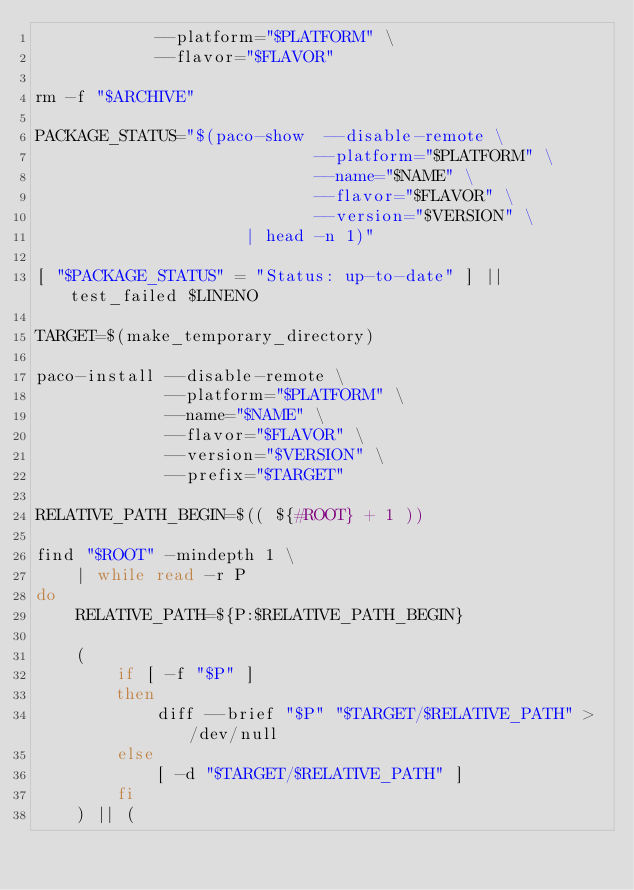<code> <loc_0><loc_0><loc_500><loc_500><_Bash_>            --platform="$PLATFORM" \
            --flavor="$FLAVOR"

rm -f "$ARCHIVE"

PACKAGE_STATUS="$(paco-show  --disable-remote \
                            --platform="$PLATFORM" \
                            --name="$NAME" \
                            --flavor="$FLAVOR" \
                            --version="$VERSION" \
                     | head -n 1)"               

[ "$PACKAGE_STATUS" = "Status: up-to-date" ] || test_failed $LINENO

TARGET=$(make_temporary_directory)

paco-install --disable-remote \
             --platform="$PLATFORM" \
             --name="$NAME" \
             --flavor="$FLAVOR" \
             --version="$VERSION" \
             --prefix="$TARGET"

RELATIVE_PATH_BEGIN=$(( ${#ROOT} + 1 ))

find "$ROOT" -mindepth 1 \
    | while read -r P
do
    RELATIVE_PATH=${P:$RELATIVE_PATH_BEGIN}
    
    (
        if [ -f "$P" ]
        then
            diff --brief "$P" "$TARGET/$RELATIVE_PATH" > /dev/null
        else
            [ -d "$TARGET/$RELATIVE_PATH" ]
        fi
    ) || (</code> 